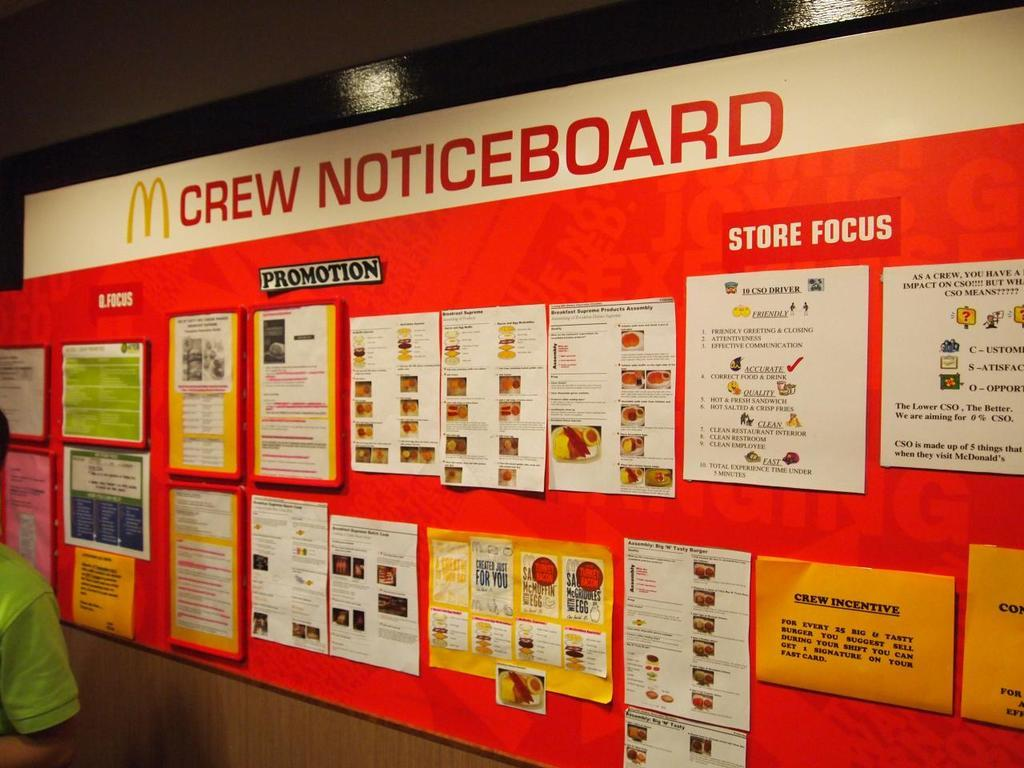<image>
Give a short and clear explanation of the subsequent image. Wall for McDonalds showing Crew notices is shown. 